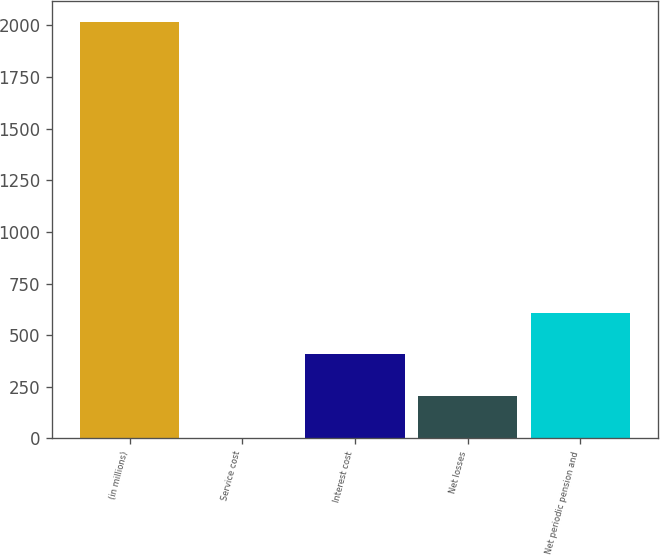Convert chart to OTSL. <chart><loc_0><loc_0><loc_500><loc_500><bar_chart><fcel>(in millions)<fcel>Service cost<fcel>Interest cost<fcel>Net losses<fcel>Net periodic pension and<nl><fcel>2018<fcel>4<fcel>406.8<fcel>205.4<fcel>608.2<nl></chart> 